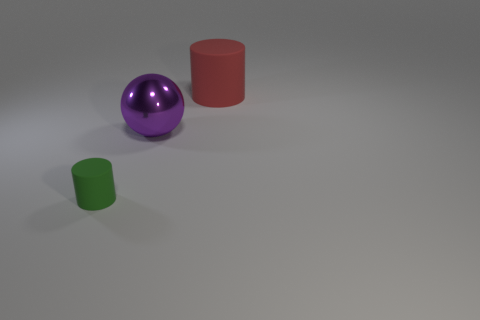Add 2 purple objects. How many objects exist? 5 Subtract all spheres. How many objects are left? 2 Subtract all purple balls. Subtract all tiny matte cylinders. How many objects are left? 1 Add 1 big rubber cylinders. How many big rubber cylinders are left? 2 Add 3 big red matte things. How many big red matte things exist? 4 Subtract 0 brown cubes. How many objects are left? 3 